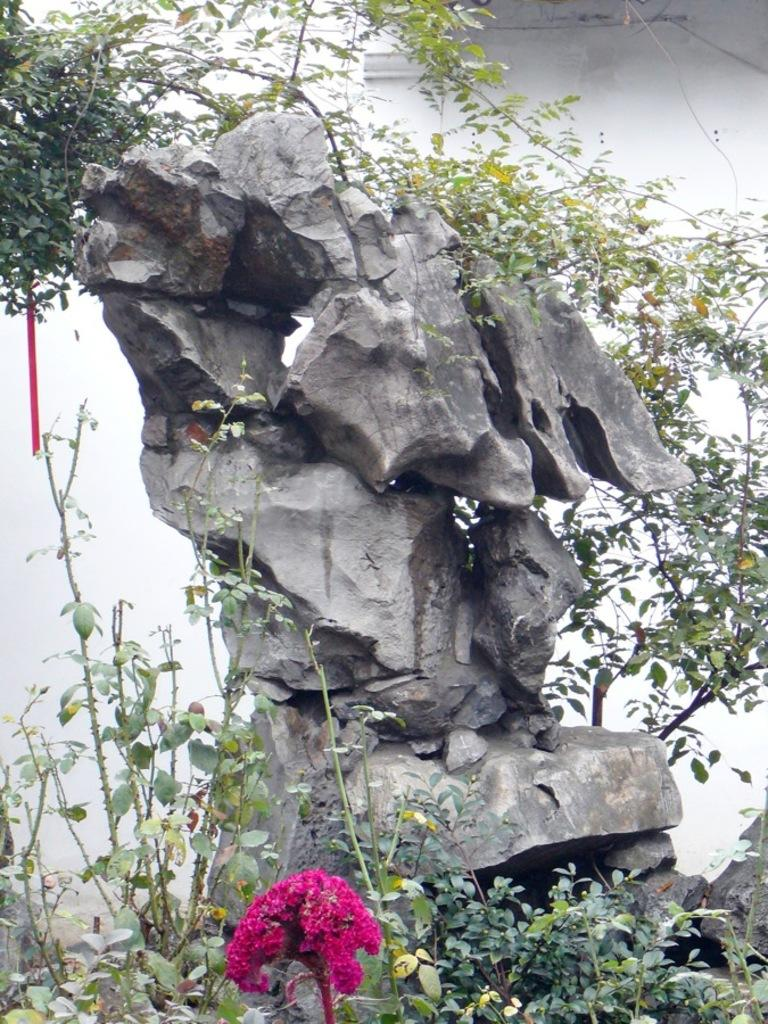What is the main subject in the front of the image? There is a flower in the front of the image. What other natural elements can be seen in the image? There are plants and leaves visible in the image. What is located in the center of the image? There is a rock in the center of the image. What can be seen in the background of the image? There is a wall in the background of the image. What color is the wall in the image? The wall is white in color. How many sisters are depicted in the image? There are no sisters present in the image; it features a flower, plants, a rock, leaves, and a wall. What type of oil can be seen dripping from the flower in the image? There is no oil present in the image; it features a flower, plants, a rock, leaves, and a wall. 